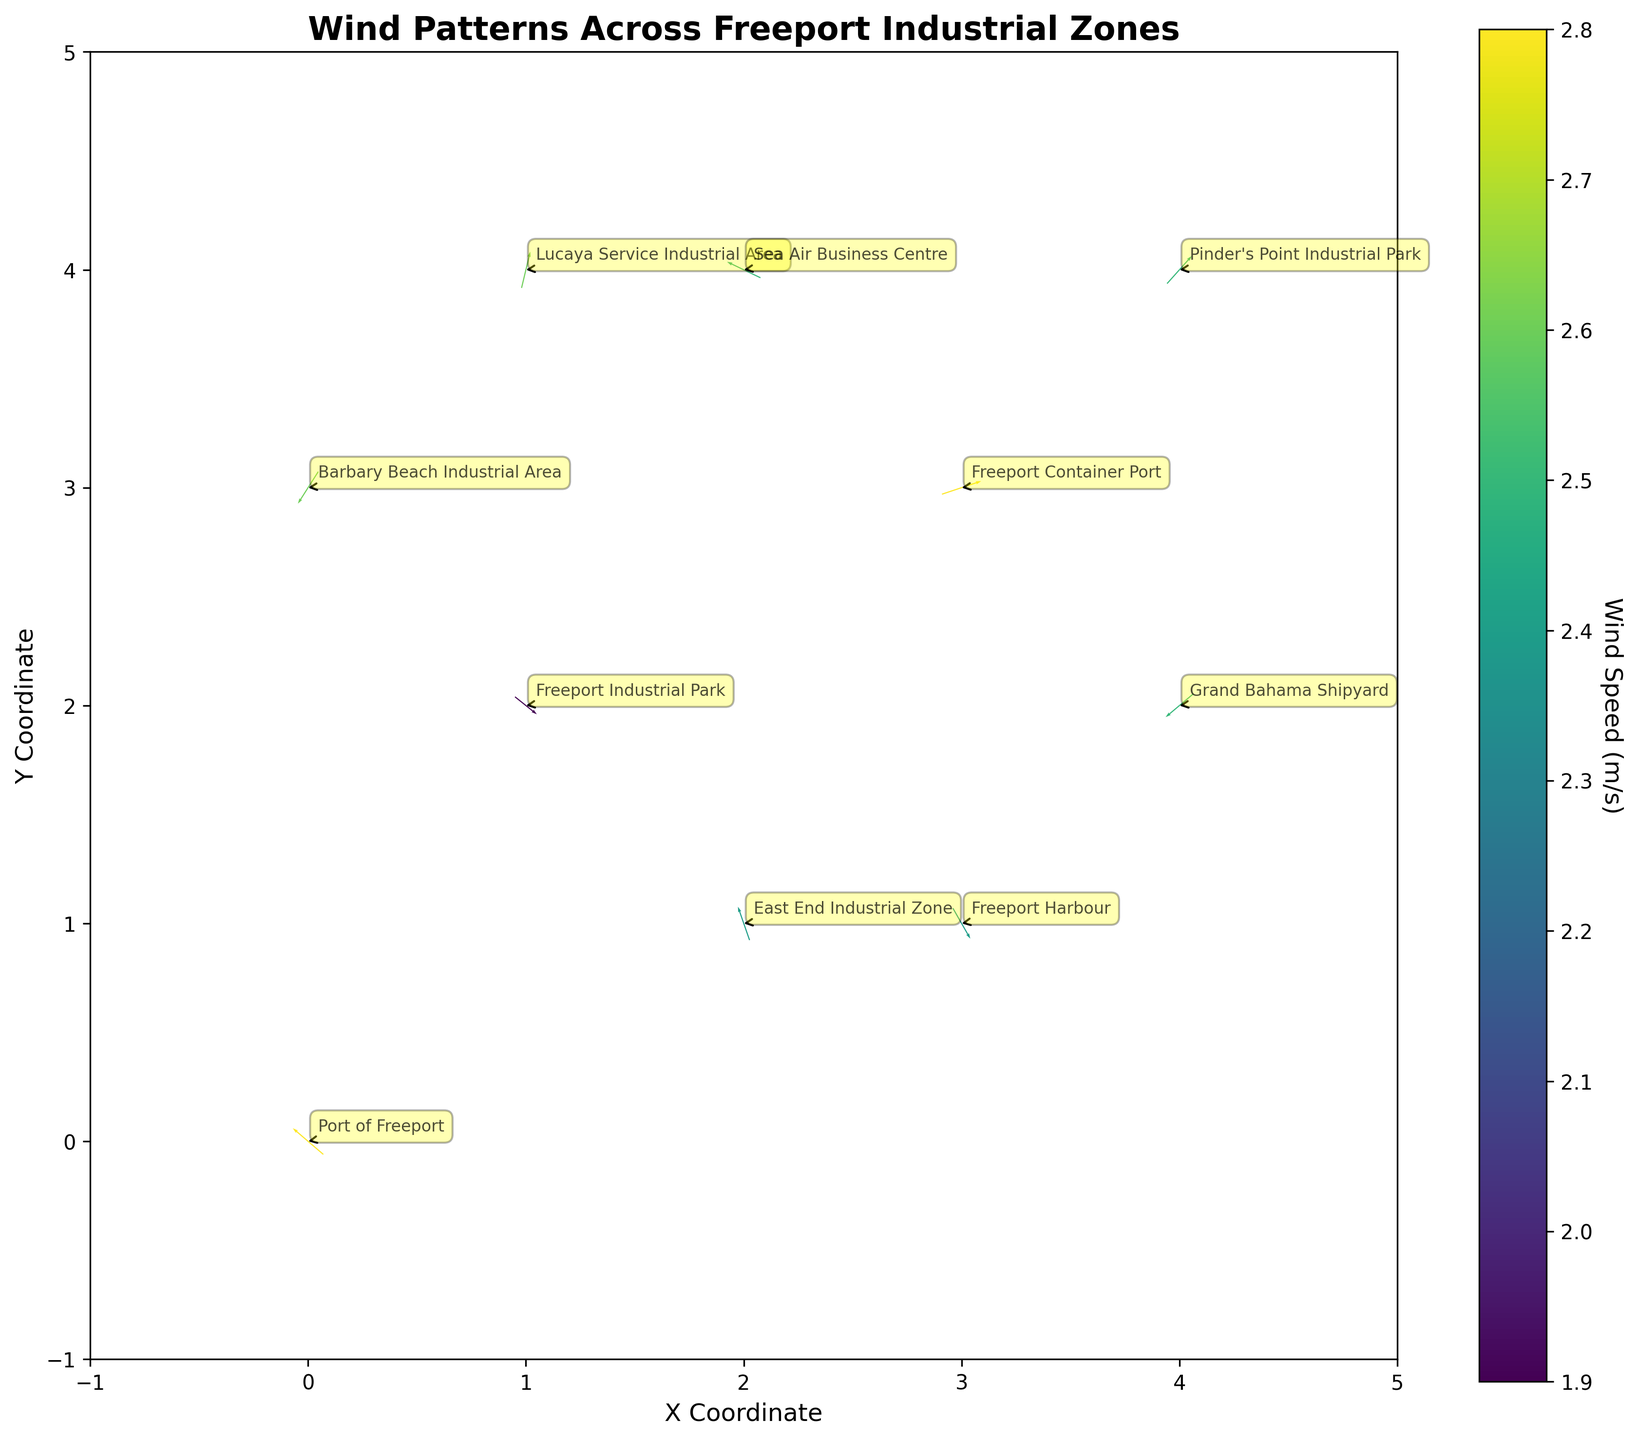What is the title of the plot? The title of the plot is found at the top center of the figure. It provides a summary of what the plot displays. In this case, the title is "Wind Patterns Across Freeport Industrial Zones."
Answer: Wind Patterns Across Freeport Industrial Zones What does the colorbar represent? The colorbar on the right side of the plot is labeled "Wind Speed (m/s)." It indicates the wind speed corresponding to the colors shown in the plot.
Answer: Wind Speed (m/s) Which industrial zone has the highest wind speed? To determine the industrial zone with the highest wind speed, look for the darkest color on the plot and check the associated annotations. The Port of Freeport and Freeport Container Port both have speeds of 2.8 m/s.
Answer: Port of Freeport and Freeport Container Port In which direction is the wind blowing at Freeport Harbour? The direction of the wind at Freeport Harbour can be determined by the arrow originating from its coordinates (3,1). The arrow points downward and to the left (southeast).
Answer: Southeast What are the x and y coordinates for Barbary Beach Industrial Area? Locate the annotation for Barbary Beach Industrial Area, then check its coordinates. Barbary Beach Industrial Area is found at coordinates (0, 3).
Answer: (0, 3) How does the wind speed at Sea Air Business Centre compare to that at Grand Bahama Shipyard? Compare the color and the annotated wind speeds of Sea Air Business Centre and Grand Bahama Shipyard. Both areas have a wind speed of 2.5 m/s, meaning their wind speeds are equal.
Answer: Equal Among the zones located at coordinates (2,1), (3,1), and (1,4), which one has the highest vertical component of wind vector? Examine the 'v' values of the coordinates (2,1), (3,1), and (1,4). The 'v' components are 2.3, -2.1, and 2.5, respectively. Lucaya Service Industrial Area (1,4) has the highest vertical component at 2.5.
Answer: Lucaya Service Industrial Area Which zone has wind blowing in the most north-west direction? To identify the zone with the most north-west direction, look for arrows pointing up and left. Freeport Industrial Park at (1, 2) has an arrow pointing up and left with significant components (1.5, -1.2).
Answer: Freeport Industrial Park What is the average wind speed across all industrial zones? To find the average wind speed, sum the wind speeds of all zones and divide by the number of zones. The total wind speed is 25 and there are 10 zones, thus the average speed is 25/10 = 2.5 m/s.
Answer: 2.5 m/s Which zone has the smallest horizontal component of the wind vector? Check the 'u' values for all industrial zones. The smallest value is -2.3 at Sea Air Business Centre (2, 4).
Answer: Sea Air Business Centre 